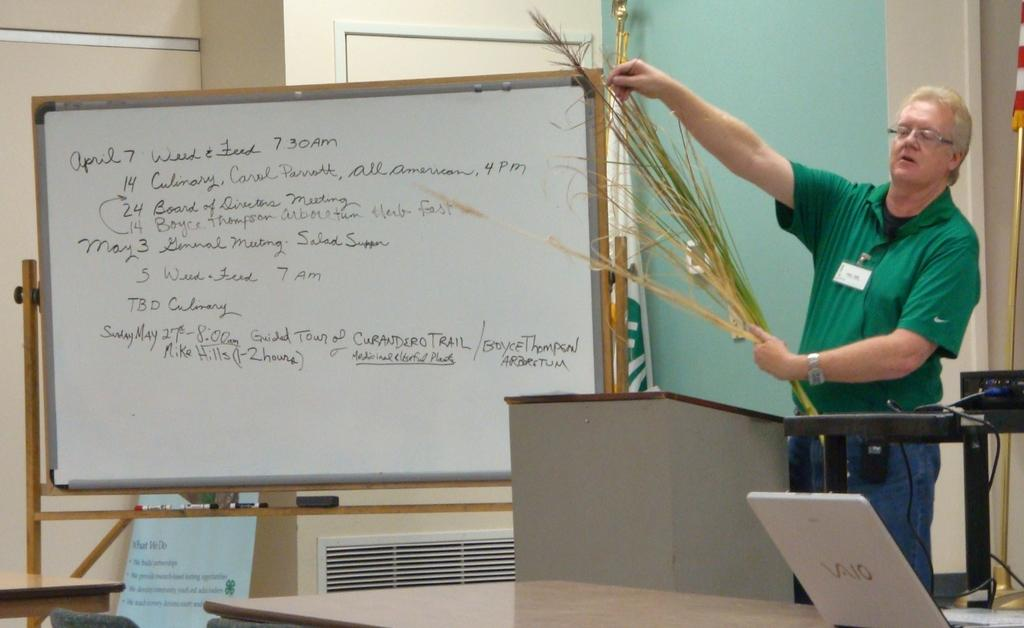<image>
Relay a brief, clear account of the picture shown. A whiteboard with the date April 7 visible. 